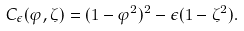<formula> <loc_0><loc_0><loc_500><loc_500>C _ { \epsilon } ( \varphi , \zeta ) = ( 1 - \varphi ^ { 2 } ) ^ { 2 } - \epsilon ( 1 - \zeta ^ { 2 } ) .</formula> 